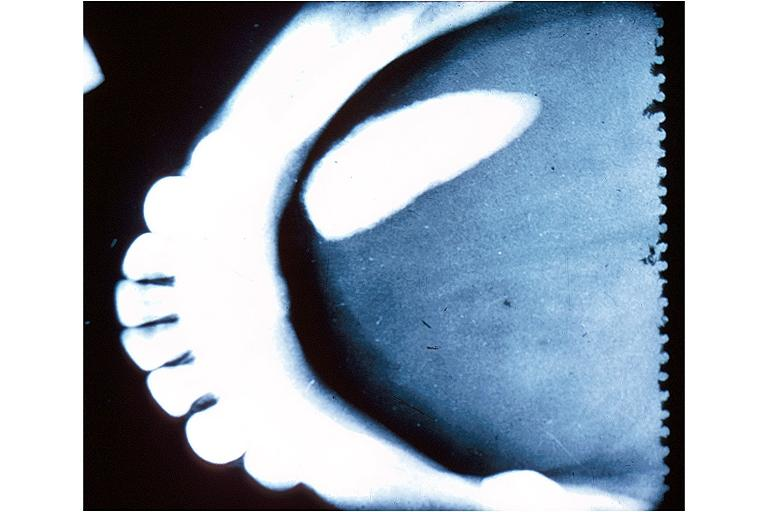where is this?
Answer the question using a single word or phrase. Oral 